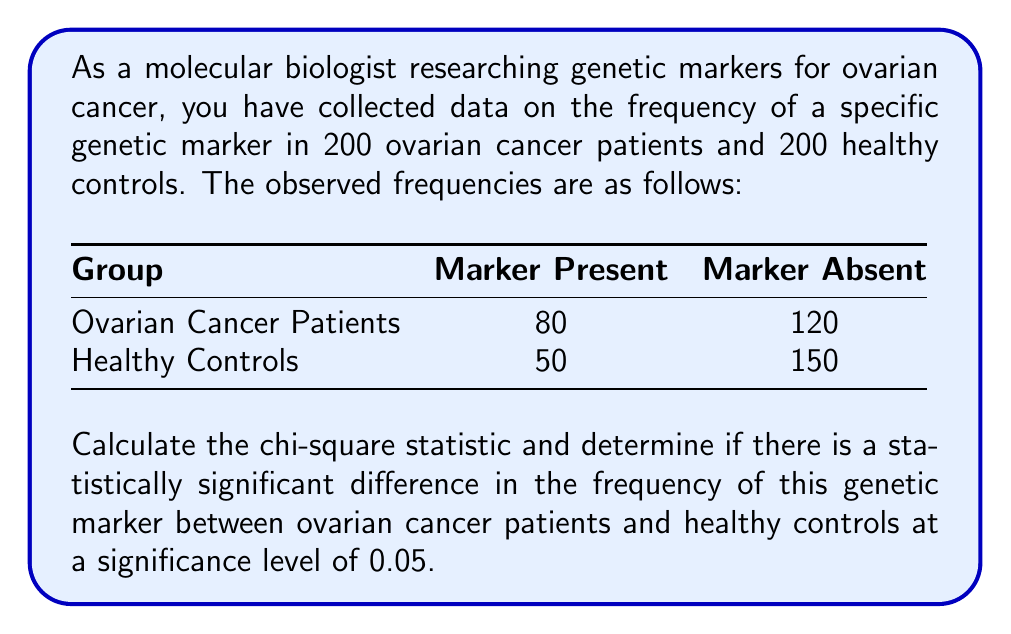Solve this math problem. To determine if there is a statistically significant difference in the frequency of the genetic marker between ovarian cancer patients and healthy controls, we'll use the chi-square test of independence. Here's the step-by-step process:

1) First, calculate the expected frequencies for each cell:

   Total sample size = 200 + 200 = 400
   Expected frequency = (row total × column total) / grand total

   For Ovarian Cancer Patients with Marker Present:
   $E_{11} = (200 × 130) / 400 = 65$

   For Ovarian Cancer Patients with Marker Absent:
   $E_{12} = (200 × 270) / 400 = 135$

   For Healthy Controls with Marker Present:
   $E_{21} = (200 × 130) / 400 = 65$

   For Healthy Controls with Marker Absent:
   $E_{22} = (200 × 270) / 400 = 135$

2) Now, calculate the chi-square statistic using the formula:

   $$\chi^2 = \sum \frac{(O - E)^2}{E}$$

   Where O is the observed frequency and E is the expected frequency.

   $\chi^2 = \frac{(80 - 65)^2}{65} + \frac{(120 - 135)^2}{135} + \frac{(50 - 65)^2}{65} + \frac{(150 - 135)^2}{135}$

   $\chi^2 = 3.46 + 1.67 + 3.46 + 1.67 = 10.26$

3) Determine the degrees of freedom:
   df = (rows - 1) × (columns - 1) = (2 - 1) × (2 - 1) = 1

4) Find the critical value for χ² with df = 1 and α = 0.05:
   The critical value is 3.841 (from a chi-square distribution table)

5) Compare the calculated χ² value to the critical value:
   10.26 > 3.841

Since the calculated χ² value (10.26) is greater than the critical value (3.841), we reject the null hypothesis of independence.
Answer: $\chi^2 = 10.26$, p < 0.05. Statistically significant difference. 